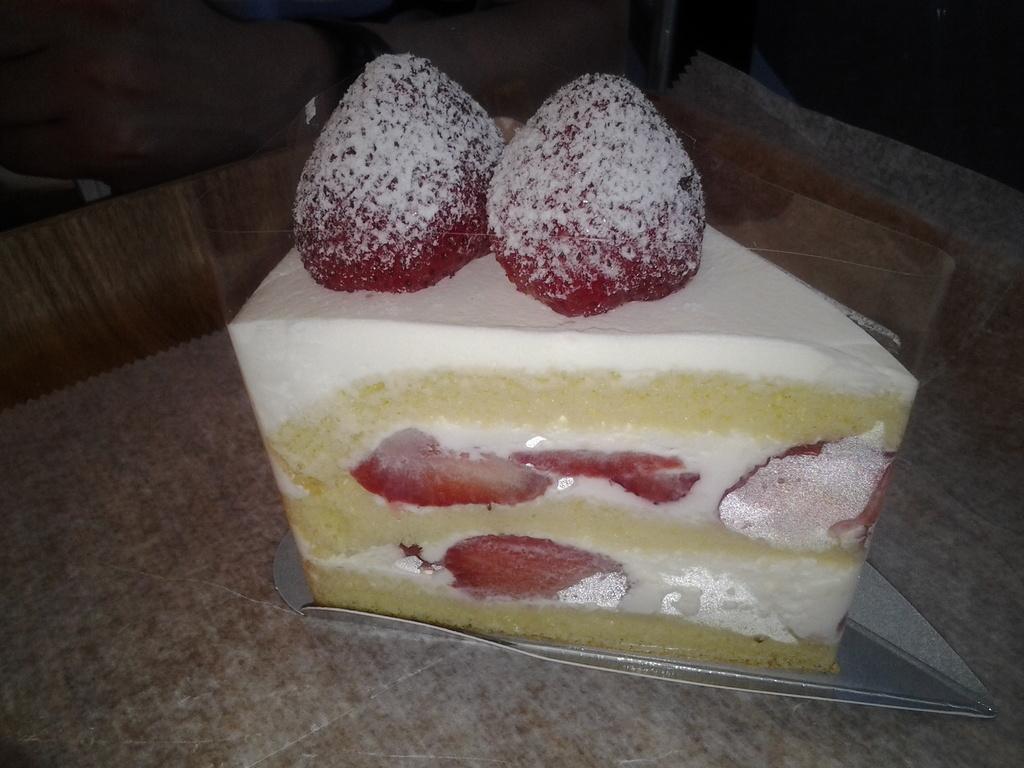Can you describe this image briefly? In this image there is a pastry topped with two strawberries and the pastry is on the table. 